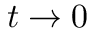<formula> <loc_0><loc_0><loc_500><loc_500>t \rightarrow 0</formula> 